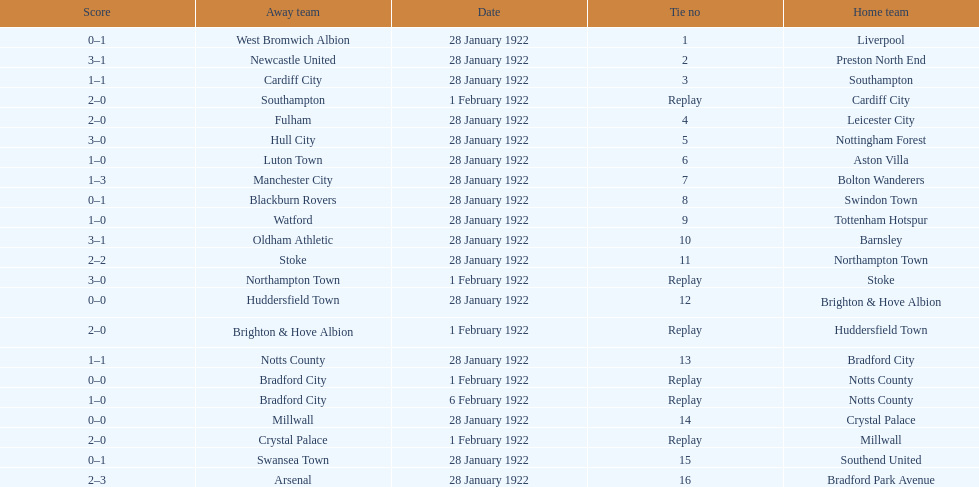Who is the first home team listed as having a score of 3-1? Preston North End. 